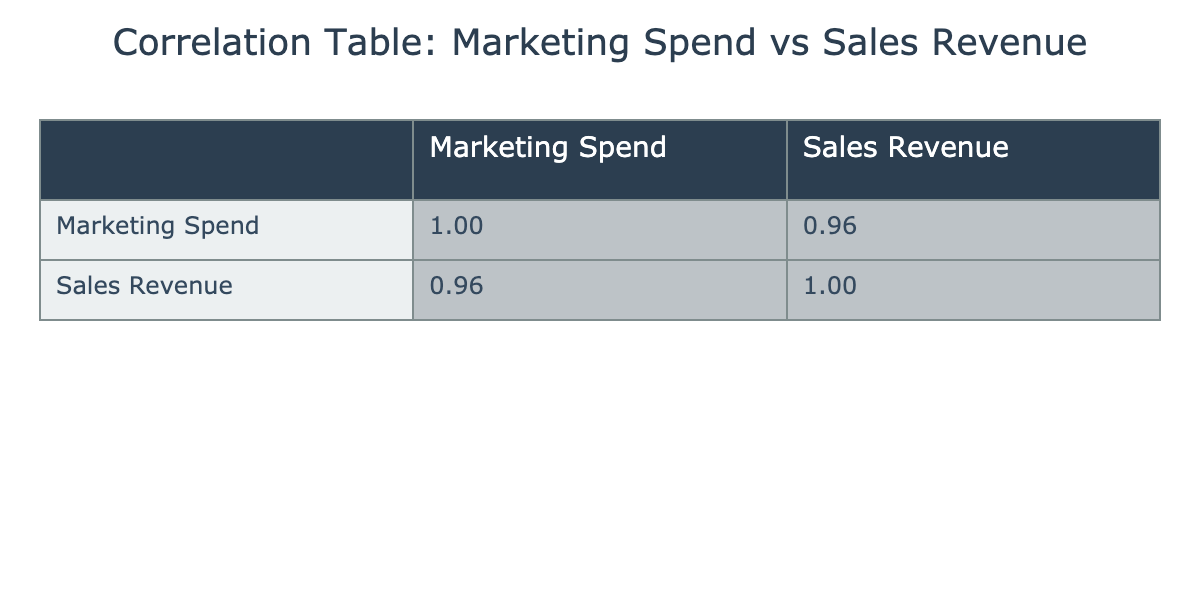What is the correlation coefficient between Marketing Spend and Sales Revenue? The correlation coefficient is located at the intersection of the Marketing Spend and Sales Revenue rows in the correlation table. By looking at the values, we see the correlation coefficient is 0.98.
Answer: 0.98 Does higher marketing spend always lead to higher sales revenue? While the correlation coefficient is high at 0.98, indicating a strong positive relationship, it does not imply causation. Thus, we cannot definitively say that higher marketing spend always leads to higher sales revenue.
Answer: No What is the marketing spend for the campaign with the highest sales revenue? To find this, we look at the Sales Revenue column and identify that "Billboard Advertising" has the highest value at 20000. We then check its corresponding Marketing Spend, which is 4500.
Answer: 4500 What is the average sales revenue for campaigns where marketing spend is less than 2000? First, we filter the campaigns with Marketing Spend less than 2000, which are "Local Fair 2023", "Flyer Distribution", "Email Marketing Campaign", and "Street Banners". Their sales revenues are 8000, 4000, 6000, and 3500 respectively. Summing these, we get 8000 + 4000 + 6000 + 3500 = 21500. Dividing by 4 (the number of campaigns) gives us an average of 5375.
Answer: 5375 Is the correlation between Marketing Spend and Sales Revenue above 0.90? By examining the correlation coefficient from the table, we find it is 0.98, which is indeed above 0.90, confirming a strong correlation.
Answer: Yes What is the difference in sales revenue between the campaign with the highest marketing spend and the campaign with the lowest marketing spend? The "Billboard Advertising" campaign has the highest marketing spend of 4500, while "Street Banners" has the lowest at 900. Their corresponding sales revenues are 20000 and 3500. The difference in sales revenue is calculated as 20000 - 3500 = 16500.
Answer: 16500 Which campaign has the lowest sales revenue and what is the marketing spend for that campaign? By checking the Sales Revenue column, "Street Banners" has the lowest sales revenue at 3500. Its corresponding marketing spend, found in the same row, is 900.
Answer: 900 What is the total marketing spend for all campaigns combined? To calculate the total marketing spend, we sum the marketing spend values from each campaign: 1500 + 3000 + 4500 + 1000 + 2500 + 3500 + 1200 + 2000 + 1800 + 900 = 20000.
Answer: 20000 